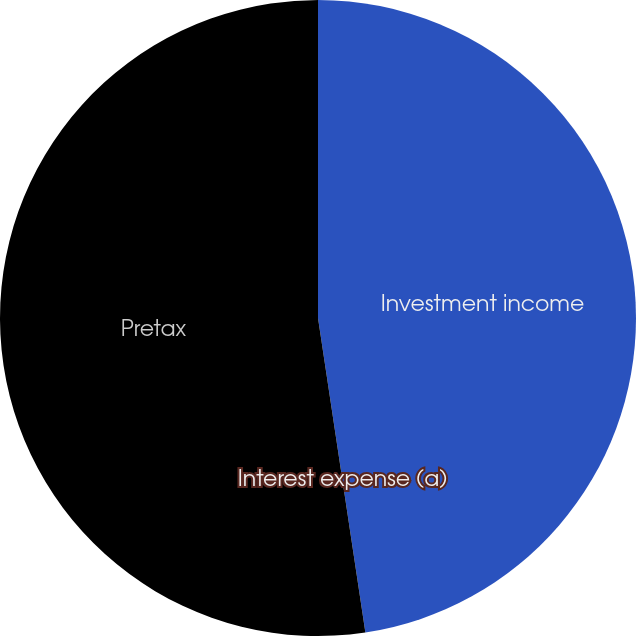Convert chart to OTSL. <chart><loc_0><loc_0><loc_500><loc_500><pie_chart><fcel>Investment income<fcel>Interest expense (a)<fcel>Pretax<nl><fcel>47.62%<fcel>0.0%<fcel>52.38%<nl></chart> 